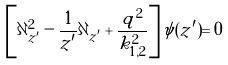<formula> <loc_0><loc_0><loc_500><loc_500>\left [ \partial _ { z ^ { \prime } } ^ { 2 } - \frac { 1 } { z ^ { \prime } } \partial _ { z ^ { \prime } } + \frac { q ^ { 2 } } { k _ { 1 , 2 } ^ { 2 } } \right ] \psi ( z ^ { \prime } ) = 0</formula> 